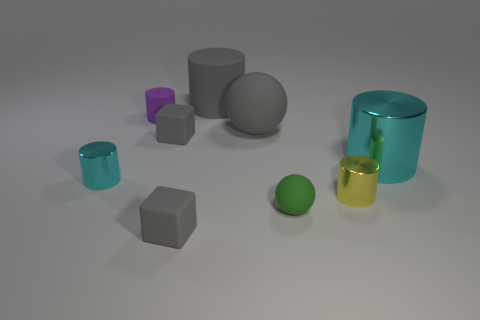There is a object that is both on the left side of the big rubber cylinder and in front of the yellow metallic object; what is its size?
Your answer should be compact. Small. Are there any other things that are made of the same material as the purple cylinder?
Make the answer very short. Yes. Does the tiny green ball have the same material as the cyan thing that is on the right side of the gray rubber cylinder?
Your answer should be very brief. No. Is the number of gray objects that are on the right side of the green rubber object less than the number of tiny purple objects that are in front of the purple matte cylinder?
Give a very brief answer. No. There is a large gray object to the right of the big rubber cylinder; what is it made of?
Offer a very short reply. Rubber. There is a cylinder that is behind the large metallic object and in front of the gray cylinder; what color is it?
Provide a short and direct response. Purple. How many other things are the same color as the big shiny cylinder?
Your response must be concise. 1. There is a big cylinder on the left side of the big rubber ball; what color is it?
Give a very brief answer. Gray. Are there any metal things of the same size as the green sphere?
Keep it short and to the point. Yes. What material is the cyan cylinder that is the same size as the green matte sphere?
Offer a terse response. Metal. 